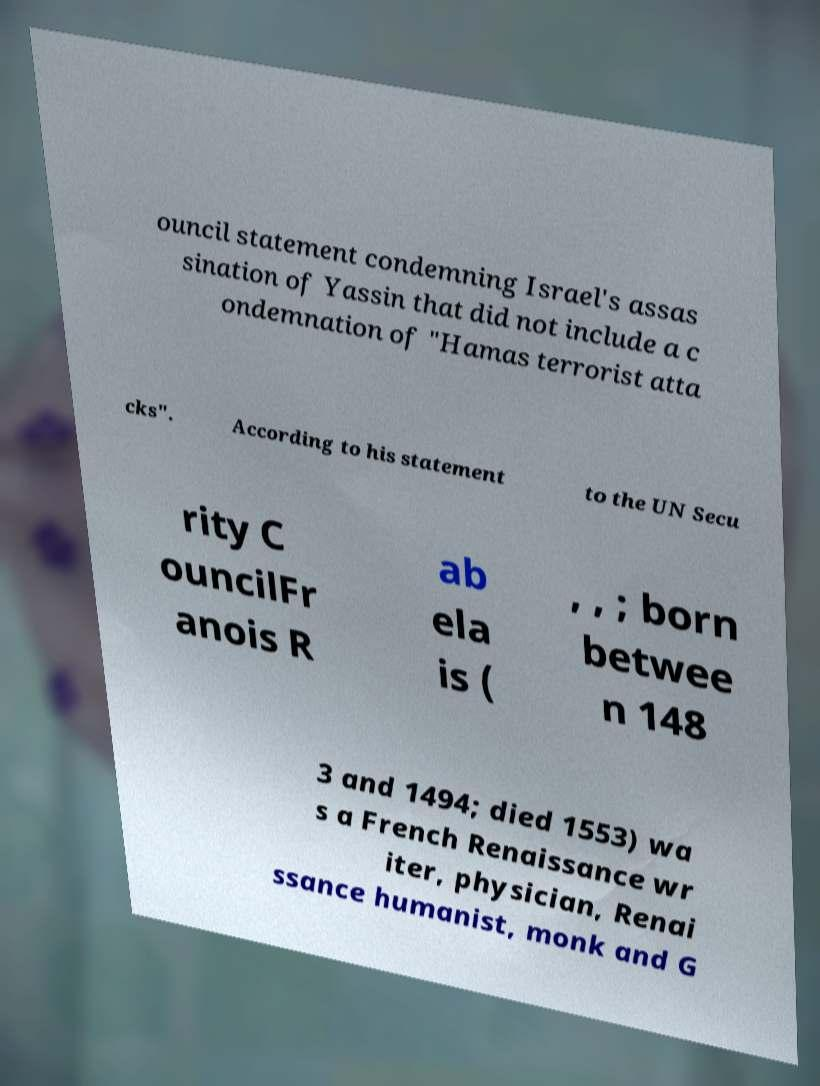What messages or text are displayed in this image? I need them in a readable, typed format. ouncil statement condemning Israel's assas sination of Yassin that did not include a c ondemnation of "Hamas terrorist atta cks". According to his statement to the UN Secu rity C ouncilFr anois R ab ela is ( , , ; born betwee n 148 3 and 1494; died 1553) wa s a French Renaissance wr iter, physician, Renai ssance humanist, monk and G 